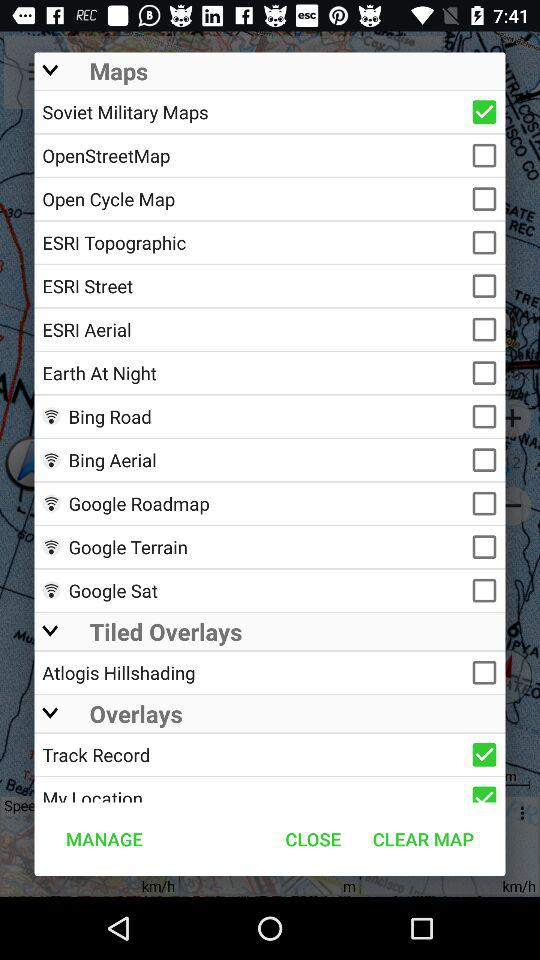Which of the checkboxes has been checked? The checkboxes that have been checked are "Soviet Military Maps", "Track Record" and "My Location". 